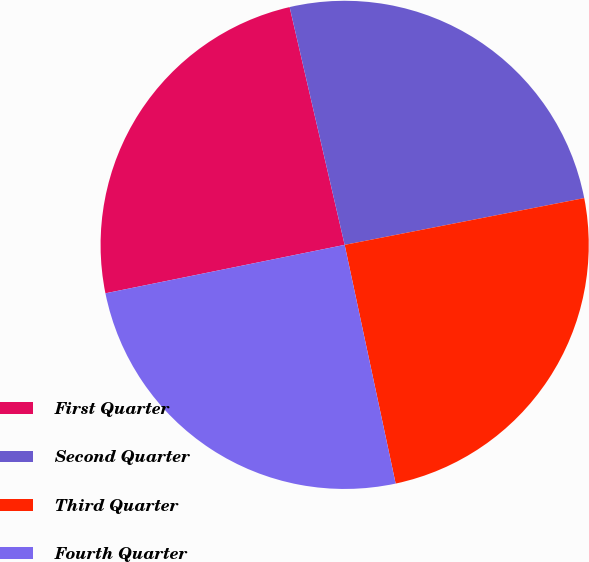Convert chart. <chart><loc_0><loc_0><loc_500><loc_500><pie_chart><fcel>First Quarter<fcel>Second Quarter<fcel>Third Quarter<fcel>Fourth Quarter<nl><fcel>24.56%<fcel>25.55%<fcel>24.72%<fcel>25.17%<nl></chart> 